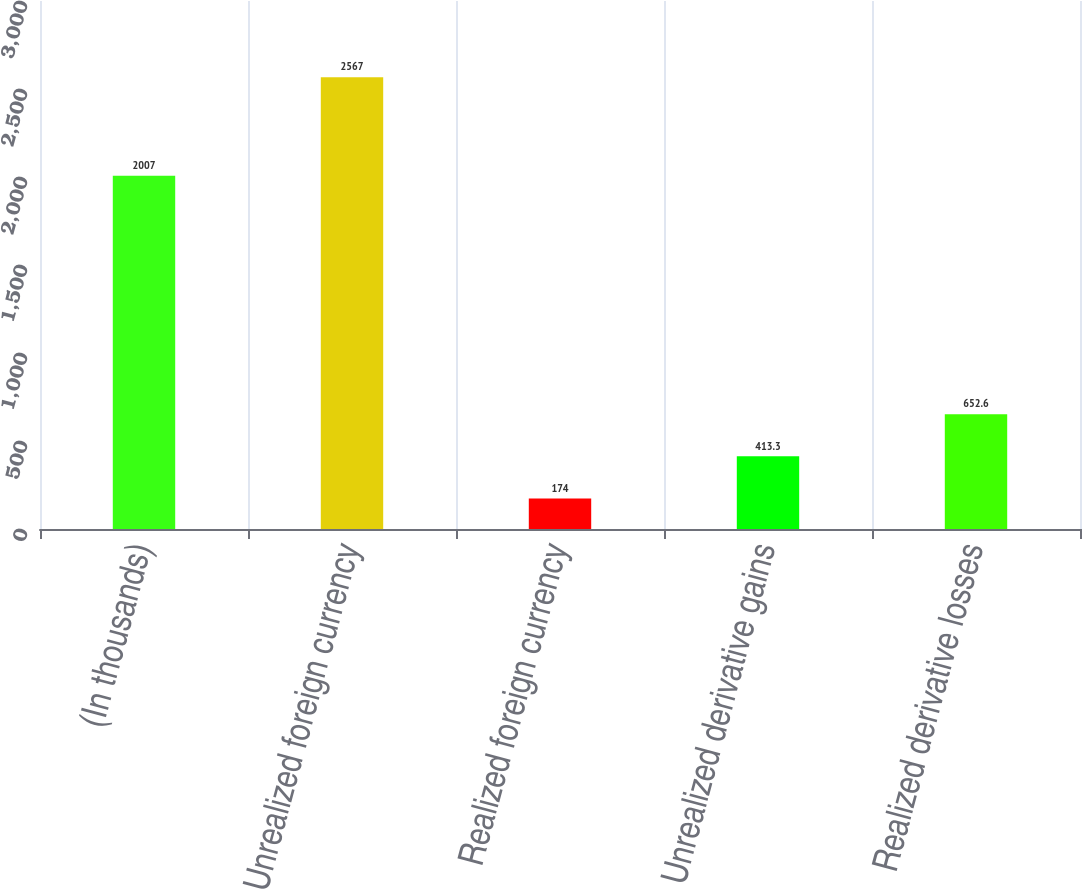Convert chart. <chart><loc_0><loc_0><loc_500><loc_500><bar_chart><fcel>(In thousands)<fcel>Unrealized foreign currency<fcel>Realized foreign currency<fcel>Unrealized derivative gains<fcel>Realized derivative losses<nl><fcel>2007<fcel>2567<fcel>174<fcel>413.3<fcel>652.6<nl></chart> 